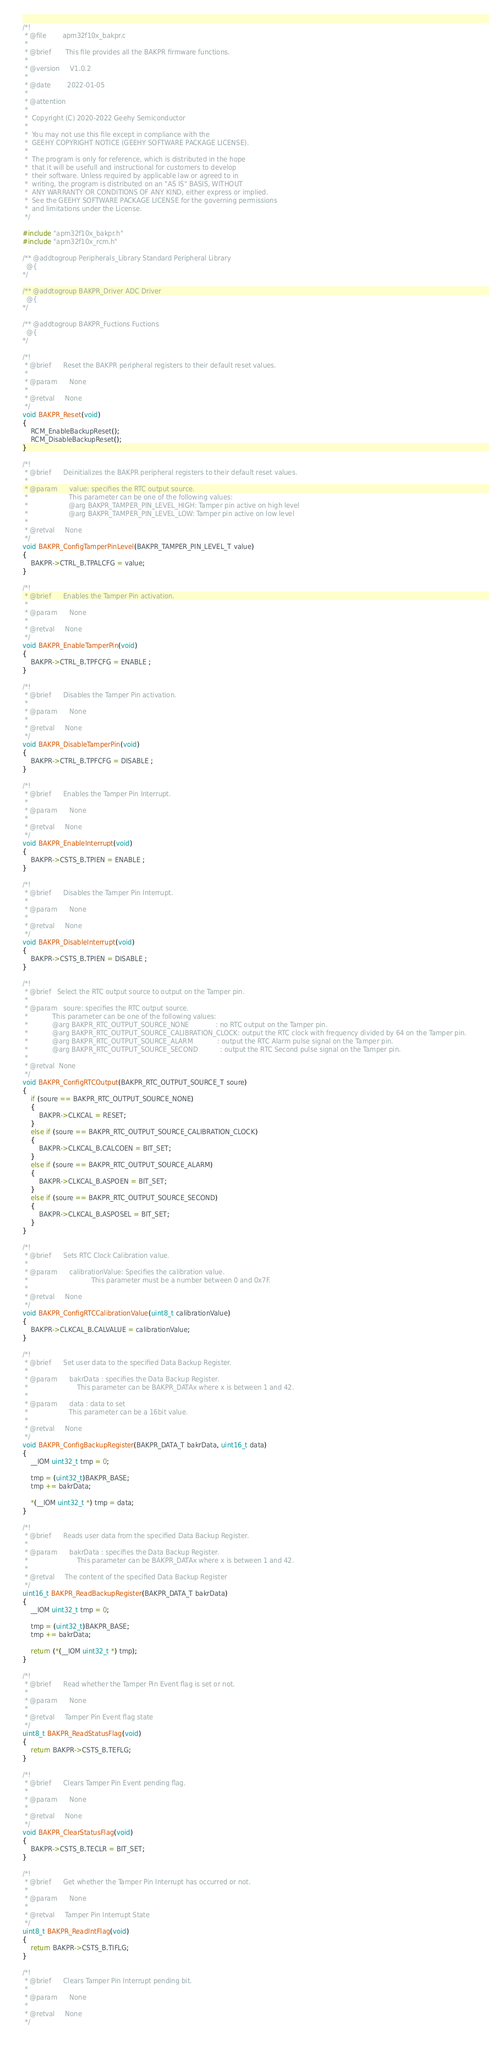Convert code to text. <code><loc_0><loc_0><loc_500><loc_500><_C_>/*!
 * @file        apm32f10x_bakpr.c
 *
 * @brief       This file provides all the BAKPR firmware functions.
 *
 * @version     V1.0.2
 *
 * @date        2022-01-05
 *
 * @attention
 *
 *  Copyright (C) 2020-2022 Geehy Semiconductor
 *
 *  You may not use this file except in compliance with the
 *  GEEHY COPYRIGHT NOTICE (GEEHY SOFTWARE PACKAGE LICENSE).
 *
 *  The program is only for reference, which is distributed in the hope
 *  that it will be usefull and instructional for customers to develop
 *  their software. Unless required by applicable law or agreed to in
 *  writing, the program is distributed on an "AS IS" BASIS, WITHOUT
 *  ANY WARRANTY OR CONDITIONS OF ANY KIND, either express or implied.
 *  See the GEEHY SOFTWARE PACKAGE LICENSE for the governing permissions
 *  and limitations under the License.
 */

#include "apm32f10x_bakpr.h"
#include "apm32f10x_rcm.h"

/** @addtogroup Peripherals_Library Standard Peripheral Library
  @{
*/

/** @addtogroup BAKPR_Driver ADC Driver
  @{
*/

/** @addtogroup BAKPR_Fuctions Fuctions
  @{
*/

/*!
 * @brief      Reset the BAKPR peripheral registers to their default reset values.
 *
 * @param      None
 *
 * @retval     None
 */
void BAKPR_Reset(void)
{
    RCM_EnableBackupReset();
    RCM_DisableBackupReset();
}

/*!
 * @brief      Deinitializes the BAKPR peripheral registers to their default reset values.
 *
 * @param      value: specifies the RTC output source.
 *                    This parameter can be one of the following values:
 *                    @arg BAKPR_TAMPER_PIN_LEVEL_HIGH: Tamper pin active on high level
 *                    @arg BAKPR_TAMPER_PIN_LEVEL_LOW: Tamper pin active on low level
 *
 * @retval     None
 */
void BAKPR_ConfigTamperPinLevel(BAKPR_TAMPER_PIN_LEVEL_T value)
{
    BAKPR->CTRL_B.TPALCFG = value;
}

/*!
 * @brief      Enables the Tamper Pin activation.
 *
 * @param      None
 *
 * @retval     None
 */
void BAKPR_EnableTamperPin(void)
{
    BAKPR->CTRL_B.TPFCFG = ENABLE ;
}

/*!
 * @brief      Disables the Tamper Pin activation.
 *
 * @param      None
 *
 * @retval     None
 */
void BAKPR_DisableTamperPin(void)
{
    BAKPR->CTRL_B.TPFCFG = DISABLE ;
}

/*!
 * @brief      Enables the Tamper Pin Interrupt.
 *
 * @param      None
 *
 * @retval     None
 */
void BAKPR_EnableInterrupt(void)
{
    BAKPR->CSTS_B.TPIEN = ENABLE ;
}

/*!
 * @brief      Disables the Tamper Pin Interrupt.
 *
 * @param      None
 *
 * @retval     None
 */
void BAKPR_DisableInterrupt(void)
{
    BAKPR->CSTS_B.TPIEN = DISABLE ;
}

/*!
 * @brief   Select the RTC output source to output on the Tamper pin.
 *
 * @param   soure: specifies the RTC output source.
 *            This parameter can be one of the following values:
 *            @arg BAKPR_RTC_OUTPUT_SOURCE_NONE             : no RTC output on the Tamper pin.
 *            @arg BAKPR_RTC_OUTPUT_SOURCE_CALIBRATION_CLOCK: output the RTC clock with frequency divided by 64 on the Tamper pin.
 *            @arg BAKPR_RTC_OUTPUT_SOURCE_ALARM            : output the RTC Alarm pulse signal on the Tamper pin.
 *            @arg BAKPR_RTC_OUTPUT_SOURCE_SECOND           : output the RTC Second pulse signal on the Tamper pin.
 *
 * @retval  None
 */
void BAKPR_ConfigRTCOutput(BAKPR_RTC_OUTPUT_SOURCE_T soure)
{
    if (soure == BAKPR_RTC_OUTPUT_SOURCE_NONE)
    {
        BAKPR->CLKCAL = RESET;
    }
    else if (soure == BAKPR_RTC_OUTPUT_SOURCE_CALIBRATION_CLOCK)
    {
        BAKPR->CLKCAL_B.CALCOEN = BIT_SET;
    }
    else if (soure == BAKPR_RTC_OUTPUT_SOURCE_ALARM)
    {
        BAKPR->CLKCAL_B.ASPOEN = BIT_SET;
    }
    else if (soure == BAKPR_RTC_OUTPUT_SOURCE_SECOND)
    {
        BAKPR->CLKCAL_B.ASPOSEL = BIT_SET;
    }
}

/*!
 * @brief      Sets RTC Clock Calibration value.
 *
 * @param      calibrationValue: Specifies the calibration value.
 *                               This parameter must be a number between 0 and 0x7F.
 *
 * @retval     None
 */
void BAKPR_ConfigRTCCalibrationValue(uint8_t calibrationValue)
{
    BAKPR->CLKCAL_B.CALVALUE = calibrationValue;
}

/*!
 * @brief      Set user data to the specified Data Backup Register.
 *
 * @param      bakrData : specifies the Data Backup Register.
 *                        This parameter can be BAKPR_DATAx where x is between 1 and 42.
 *
 * @param      data : data to set
 *                    This parameter can be a 16bit value.
 *
 * @retval     None
 */
void BAKPR_ConfigBackupRegister(BAKPR_DATA_T bakrData, uint16_t data)
{
    __IOM uint32_t tmp = 0;

    tmp = (uint32_t)BAKPR_BASE;
    tmp += bakrData;

    *(__IOM uint32_t *) tmp = data;
}

/*!
 * @brief      Reads user data from the specified Data Backup Register.
 *
 * @param      bakrData : specifies the Data Backup Register.
 *                        This parameter can be BAKPR_DATAx where x is between 1 and 42.
 *
 * @retval     The content of the specified Data Backup Register
 */
uint16_t BAKPR_ReadBackupRegister(BAKPR_DATA_T bakrData)
{
    __IOM uint32_t tmp = 0;

    tmp = (uint32_t)BAKPR_BASE;
    tmp += bakrData;

    return (*(__IOM uint32_t *) tmp);
}

/*!
 * @brief      Read whether the Tamper Pin Event flag is set or not.
 *
 * @param      None
 *
 * @retval     Tamper Pin Event flag state
 */
uint8_t BAKPR_ReadStatusFlag(void)
{
    return BAKPR->CSTS_B.TEFLG;
}

/*!
 * @brief      Clears Tamper Pin Event pending flag.
 *
 * @param      None
 *
 * @retval     None
 */
void BAKPR_ClearStatusFlag(void)
{
    BAKPR->CSTS_B.TECLR = BIT_SET;
}

/*!
 * @brief      Get whether the Tamper Pin Interrupt has occurred or not.
 *
 * @param      None
 *
 * @retval     Tamper Pin Interrupt State
 */
uint8_t BAKPR_ReadIntFlag(void)
{
    return BAKPR->CSTS_B.TIFLG;
}

/*!
 * @brief      Clears Tamper Pin Interrupt pending bit.
 *
 * @param      None
 *
 * @retval     None
 */</code> 